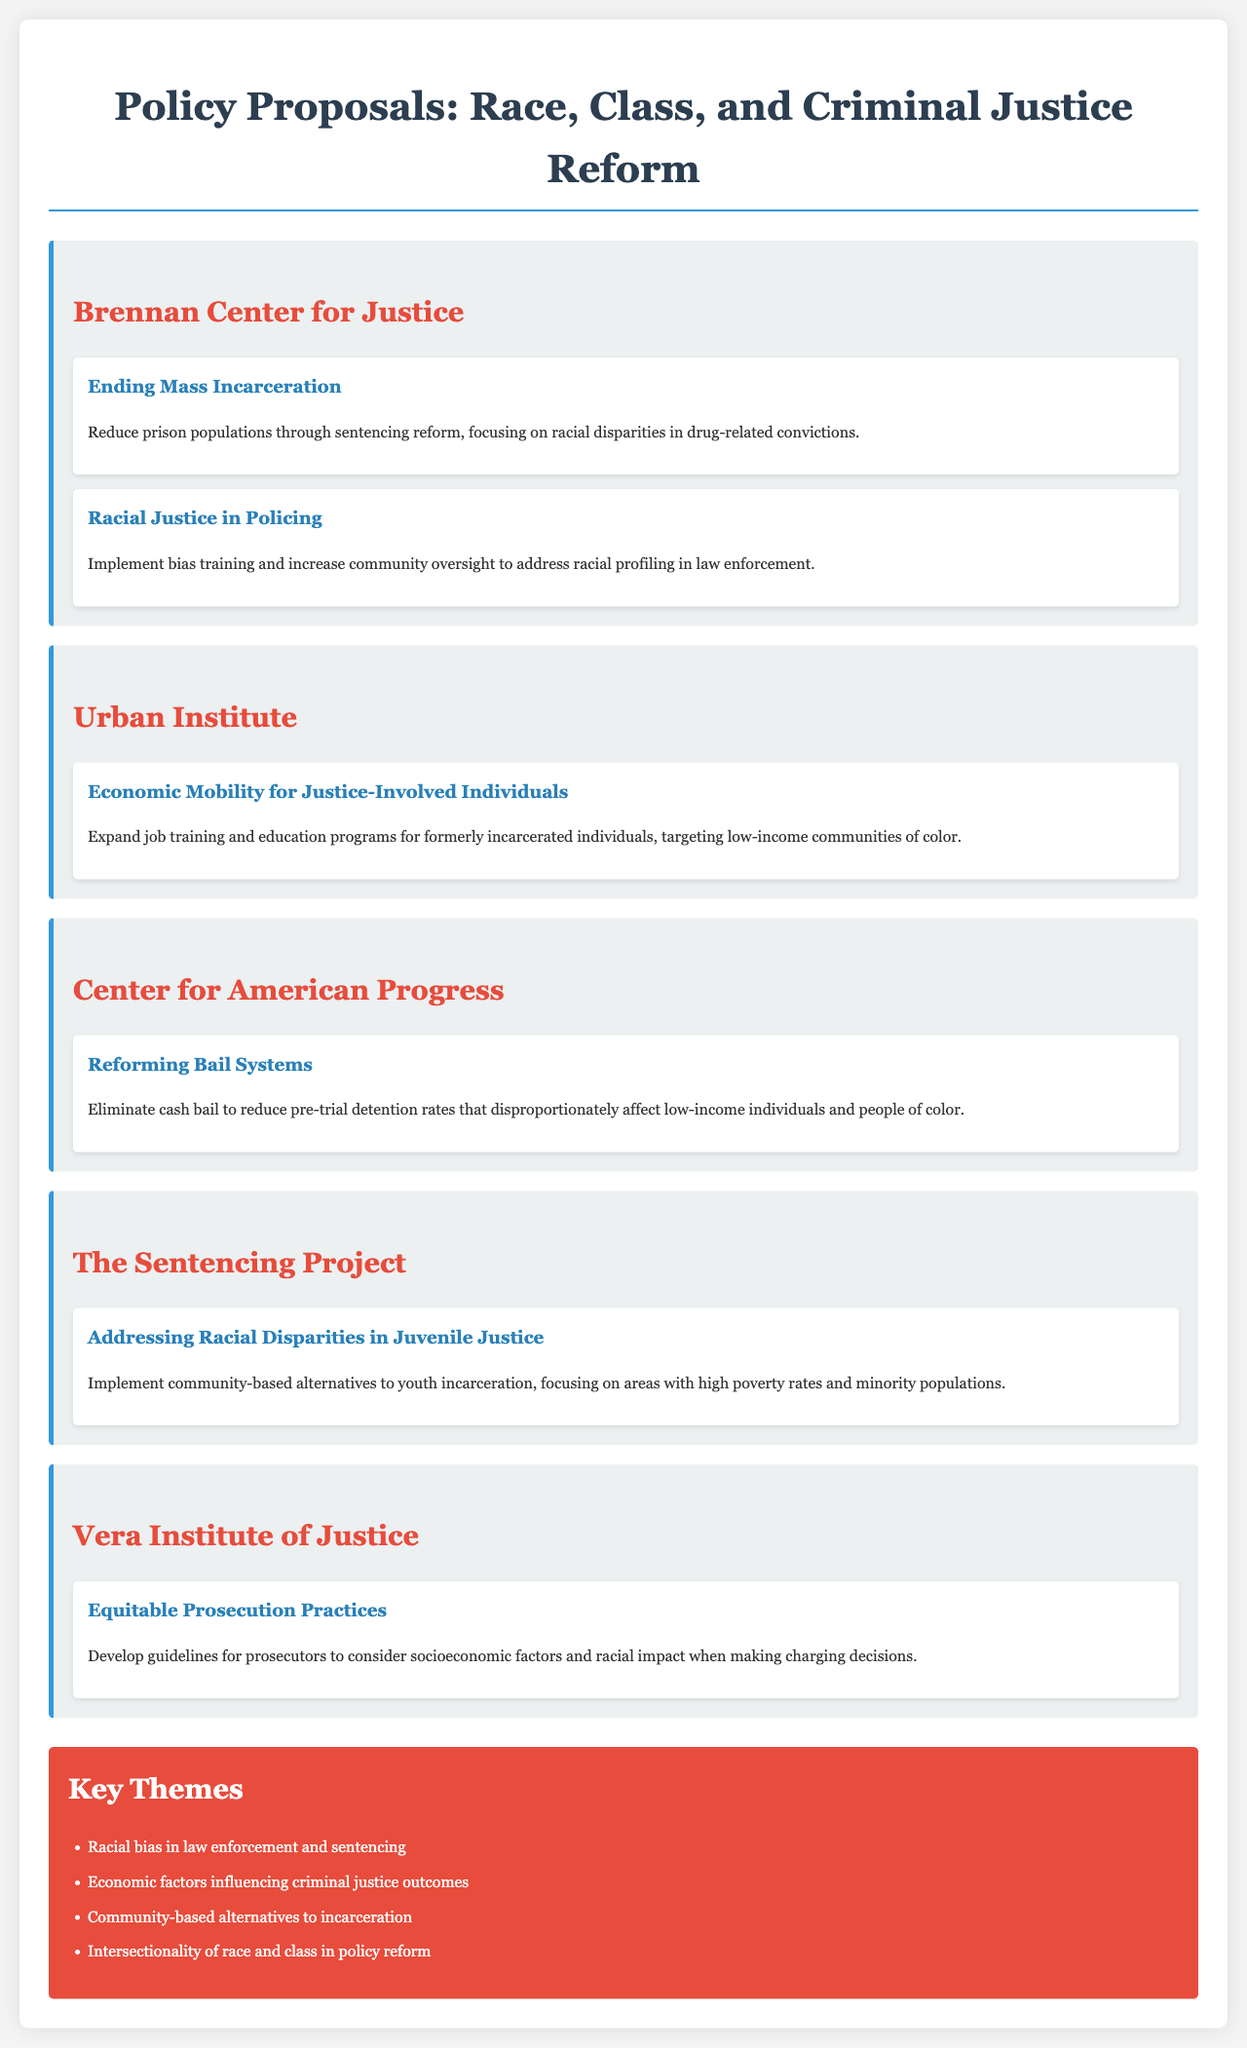What is the name of the think tank that proposes "Ending Mass Incarceration"? The think tank that proposes this is the Brennan Center for Justice.
Answer: Brennan Center for Justice How many proposals are provided by the Urban Institute? The Urban Institute has one proposal listed in the document.
Answer: 1 What reform does the Center for American Progress advocate for? They advocate for reforming bail systems to eliminate cash bail.
Answer: Reforming Bail Systems Which think tank focuses on racial disparities in juvenile justice? The think tank focusing on this issue is The Sentencing Project.
Answer: The Sentencing Project What is one key theme mentioned in the document? One key theme is "Racial bias in law enforcement and sentencing."
Answer: Racial bias in law enforcement and sentencing Which proposal targets low-income communities of color? The proposal titled "Economic Mobility for Justice-Involved Individuals" targets these communities.
Answer: Economic Mobility for Justice-Involved Individuals What is the proposed solution to address racial profiling in law enforcement? The proposed solution includes implementing bias training and increasing community oversight.
Answer: Implement bias training and increase community oversight What socioeconomic issue is linked to pre-trial detention rates? The socioeconomic issue linked is that it disproportionately affects low-income individuals and people of color.
Answer: Low-income individuals and people of color Which think tank suggests developing guidelines for prosecutors? The Vera Institute of Justice suggests this.
Answer: Vera Institute of Justice 